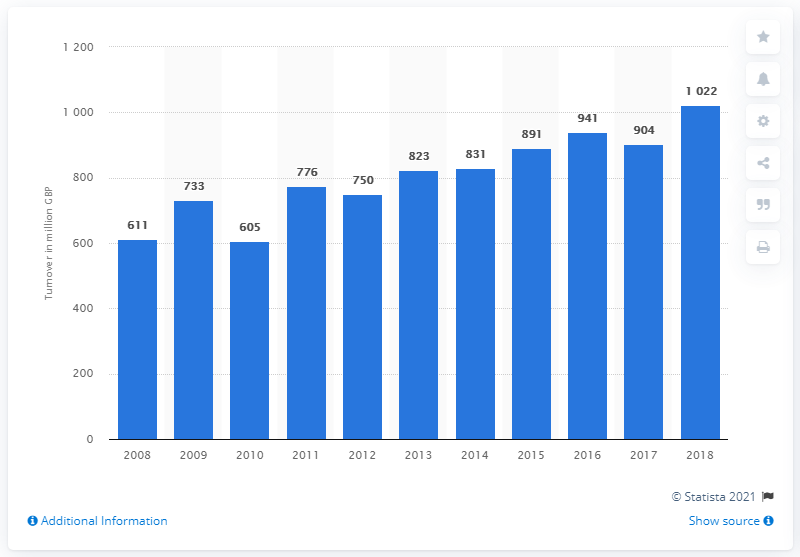Indicate a few pertinent items in this graphic. In 2018, the total revenue generated by amusement parks and theme parks reached 1022. 